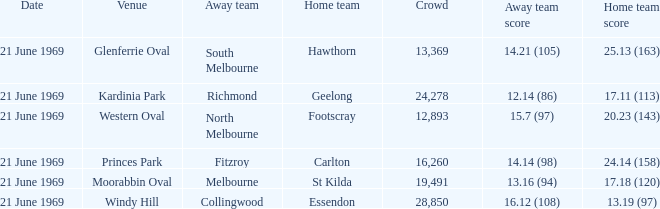When was there a game at Kardinia Park? 21 June 1969. Give me the full table as a dictionary. {'header': ['Date', 'Venue', 'Away team', 'Home team', 'Crowd', 'Away team score', 'Home team score'], 'rows': [['21 June 1969', 'Glenferrie Oval', 'South Melbourne', 'Hawthorn', '13,369', '14.21 (105)', '25.13 (163)'], ['21 June 1969', 'Kardinia Park', 'Richmond', 'Geelong', '24,278', '12.14 (86)', '17.11 (113)'], ['21 June 1969', 'Western Oval', 'North Melbourne', 'Footscray', '12,893', '15.7 (97)', '20.23 (143)'], ['21 June 1969', 'Princes Park', 'Fitzroy', 'Carlton', '16,260', '14.14 (98)', '24.14 (158)'], ['21 June 1969', 'Moorabbin Oval', 'Melbourne', 'St Kilda', '19,491', '13.16 (94)', '17.18 (120)'], ['21 June 1969', 'Windy Hill', 'Collingwood', 'Essendon', '28,850', '16.12 (108)', '13.19 (97)']]} 